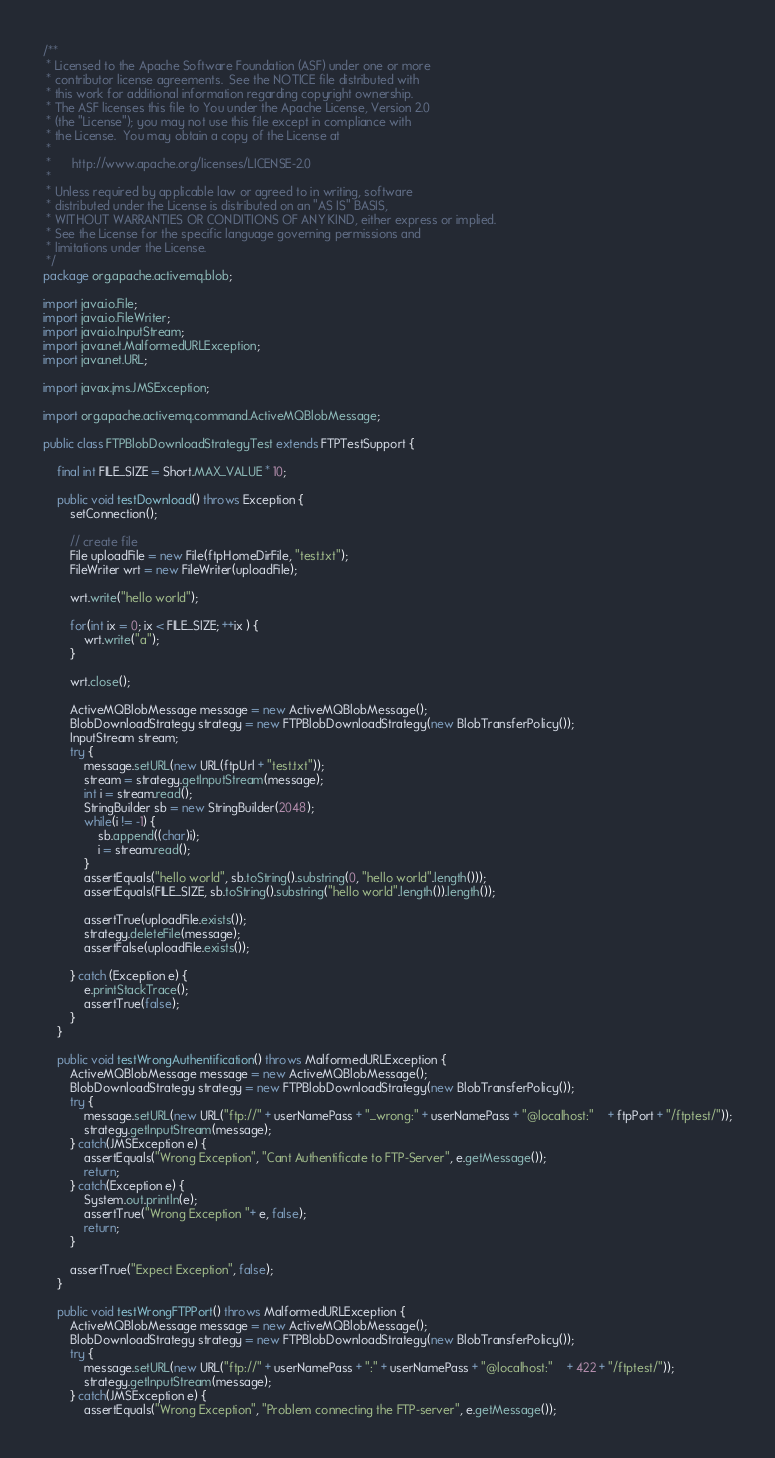<code> <loc_0><loc_0><loc_500><loc_500><_Java_>/**
 * Licensed to the Apache Software Foundation (ASF) under one or more
 * contributor license agreements.  See the NOTICE file distributed with
 * this work for additional information regarding copyright ownership.
 * The ASF licenses this file to You under the Apache License, Version 2.0
 * (the "License"); you may not use this file except in compliance with
 * the License.  You may obtain a copy of the License at
 *
 *      http://www.apache.org/licenses/LICENSE-2.0
 *
 * Unless required by applicable law or agreed to in writing, software
 * distributed under the License is distributed on an "AS IS" BASIS,
 * WITHOUT WARRANTIES OR CONDITIONS OF ANY KIND, either express or implied.
 * See the License for the specific language governing permissions and
 * limitations under the License.
 */
package org.apache.activemq.blob;

import java.io.File;
import java.io.FileWriter;
import java.io.InputStream;
import java.net.MalformedURLException;
import java.net.URL;

import javax.jms.JMSException;

import org.apache.activemq.command.ActiveMQBlobMessage;

public class FTPBlobDownloadStrategyTest extends FTPTestSupport {

    final int FILE_SIZE = Short.MAX_VALUE * 10;

    public void testDownload() throws Exception {
        setConnection();

        // create file
        File uploadFile = new File(ftpHomeDirFile, "test.txt");
        FileWriter wrt = new FileWriter(uploadFile);

        wrt.write("hello world");

        for(int ix = 0; ix < FILE_SIZE; ++ix ) {
            wrt.write("a");
        }

        wrt.close();

        ActiveMQBlobMessage message = new ActiveMQBlobMessage();
        BlobDownloadStrategy strategy = new FTPBlobDownloadStrategy(new BlobTransferPolicy());
        InputStream stream;
        try {
            message.setURL(new URL(ftpUrl + "test.txt"));
            stream = strategy.getInputStream(message);
            int i = stream.read();
            StringBuilder sb = new StringBuilder(2048);
            while(i != -1) {
                sb.append((char)i);
                i = stream.read();
            }
            assertEquals("hello world", sb.toString().substring(0, "hello world".length()));
            assertEquals(FILE_SIZE, sb.toString().substring("hello world".length()).length());

            assertTrue(uploadFile.exists());
            strategy.deleteFile(message);
            assertFalse(uploadFile.exists());

        } catch (Exception e) {
            e.printStackTrace();
            assertTrue(false);
        }
    }

    public void testWrongAuthentification() throws MalformedURLException {
        ActiveMQBlobMessage message = new ActiveMQBlobMessage();
        BlobDownloadStrategy strategy = new FTPBlobDownloadStrategy(new BlobTransferPolicy());
        try {
            message.setURL(new URL("ftp://" + userNamePass + "_wrong:" + userNamePass + "@localhost:"	+ ftpPort + "/ftptest/"));
            strategy.getInputStream(message);
        } catch(JMSException e) {
            assertEquals("Wrong Exception", "Cant Authentificate to FTP-Server", e.getMessage());
            return;
        } catch(Exception e) {
            System.out.println(e);
            assertTrue("Wrong Exception "+ e, false);
            return;
        }

        assertTrue("Expect Exception", false);
    }

    public void testWrongFTPPort() throws MalformedURLException {
        ActiveMQBlobMessage message = new ActiveMQBlobMessage();
        BlobDownloadStrategy strategy = new FTPBlobDownloadStrategy(new BlobTransferPolicy());
        try {
            message.setURL(new URL("ftp://" + userNamePass + ":" + userNamePass + "@localhost:"	+ 422 + "/ftptest/"));
            strategy.getInputStream(message);
        } catch(JMSException e) {
            assertEquals("Wrong Exception", "Problem connecting the FTP-server", e.getMessage());</code> 